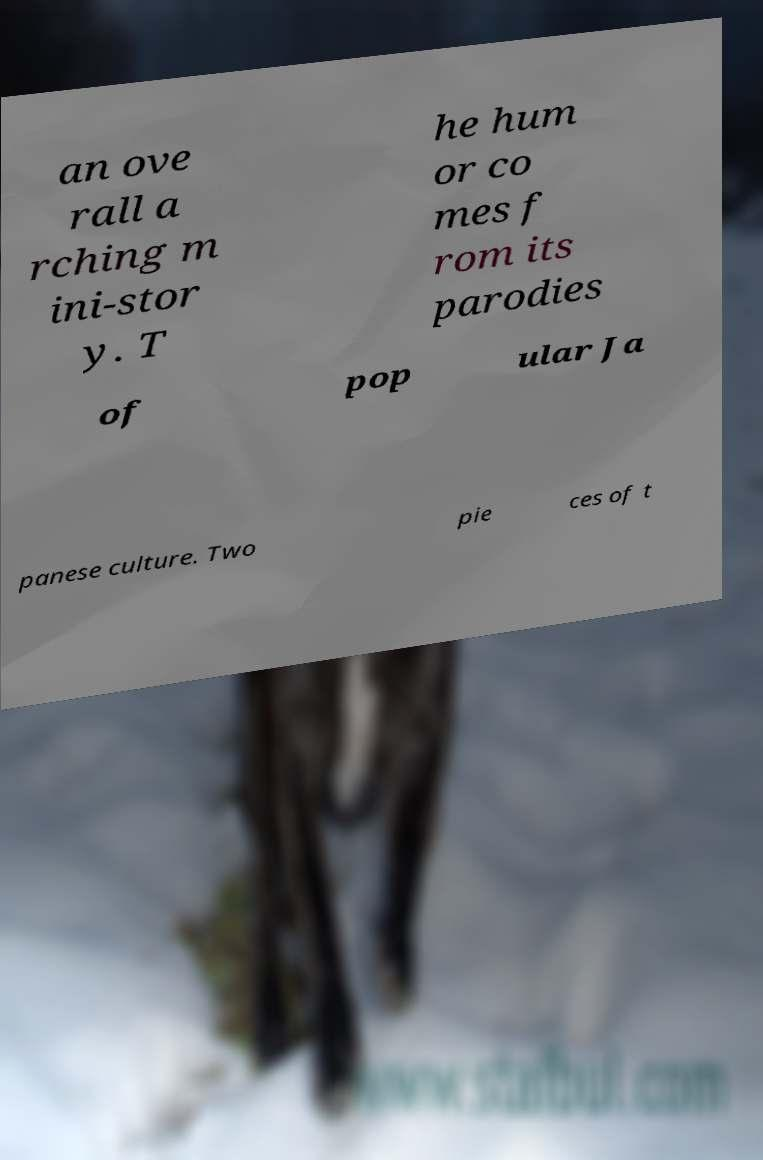Could you assist in decoding the text presented in this image and type it out clearly? an ove rall a rching m ini-stor y. T he hum or co mes f rom its parodies of pop ular Ja panese culture. Two pie ces of t 